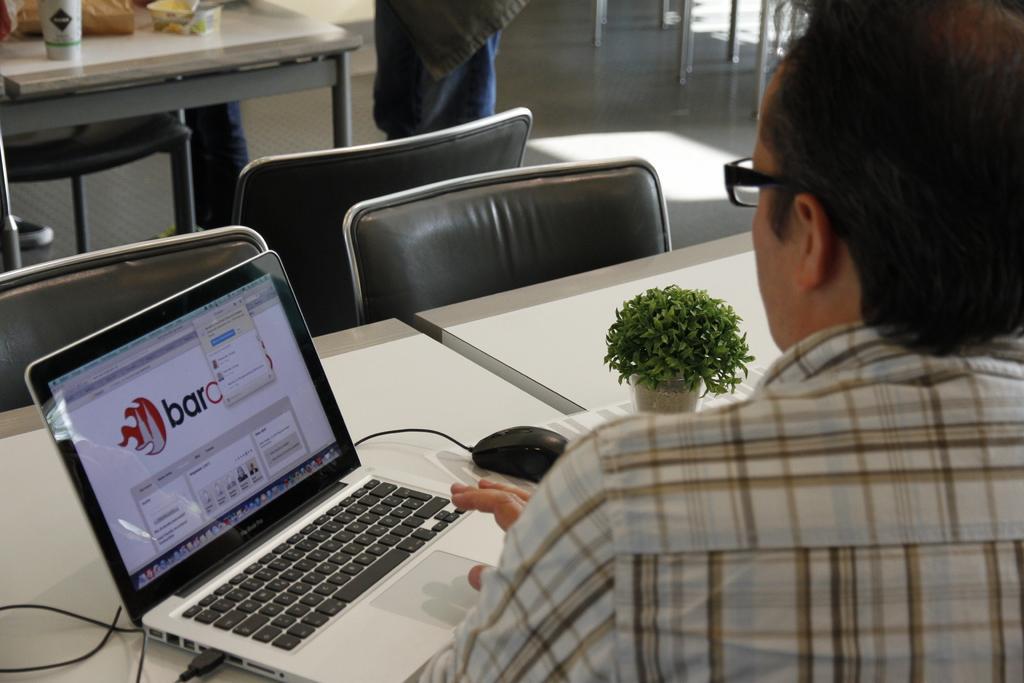In one or two sentences, can you explain what this image depicts? In the image on the right we can see one person sitting. In front of him,there is a table. On the table,there is a laptop,mouse,tissue paper and plant pot. In the background we can see chairs,tables and one person standing. On the table,there is a glass,box and few other objects. 